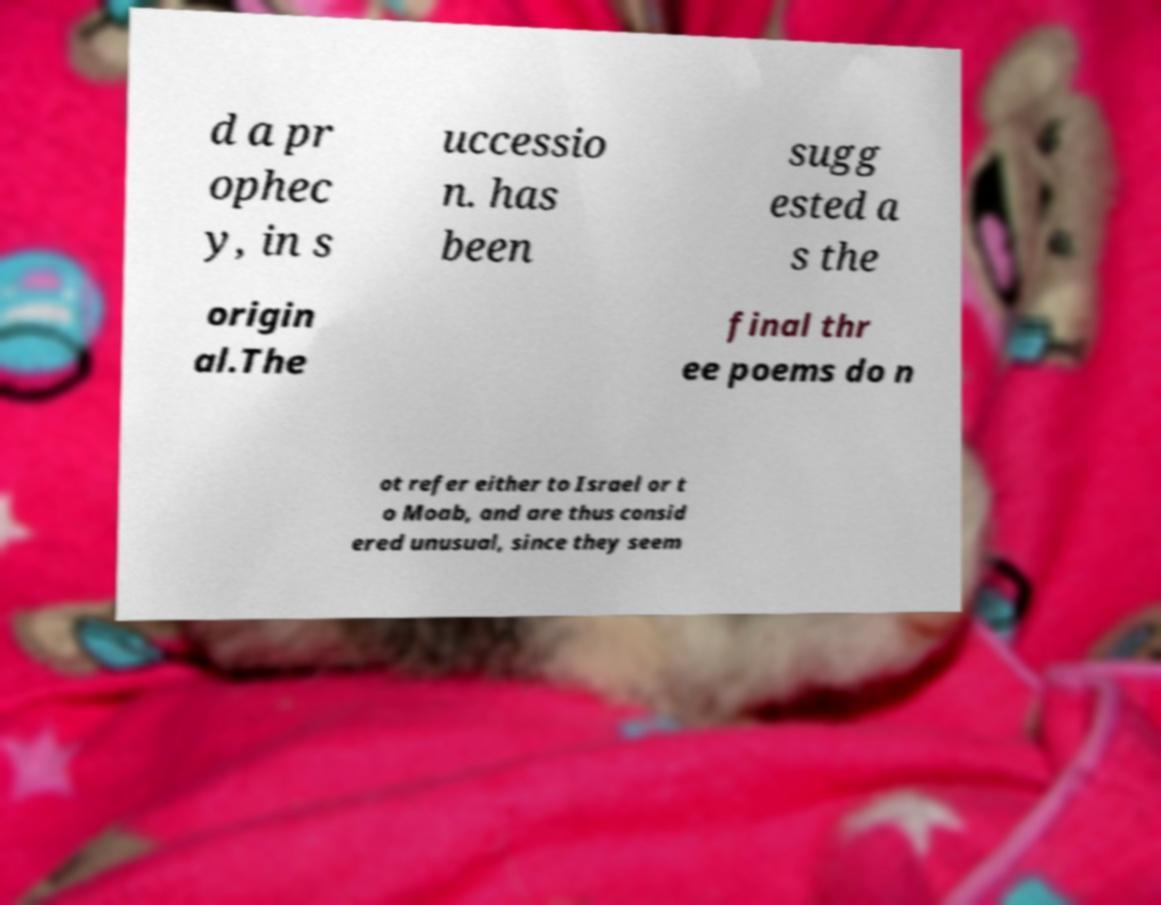What messages or text are displayed in this image? I need them in a readable, typed format. d a pr ophec y, in s uccessio n. has been sugg ested a s the origin al.The final thr ee poems do n ot refer either to Israel or t o Moab, and are thus consid ered unusual, since they seem 